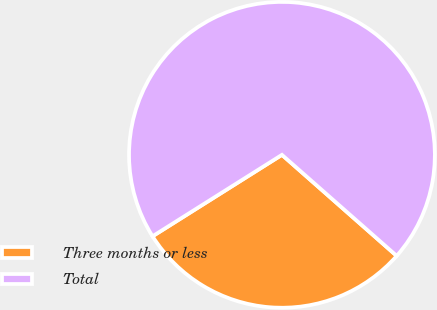Convert chart. <chart><loc_0><loc_0><loc_500><loc_500><pie_chart><fcel>Three months or less<fcel>Total<nl><fcel>29.57%<fcel>70.43%<nl></chart> 